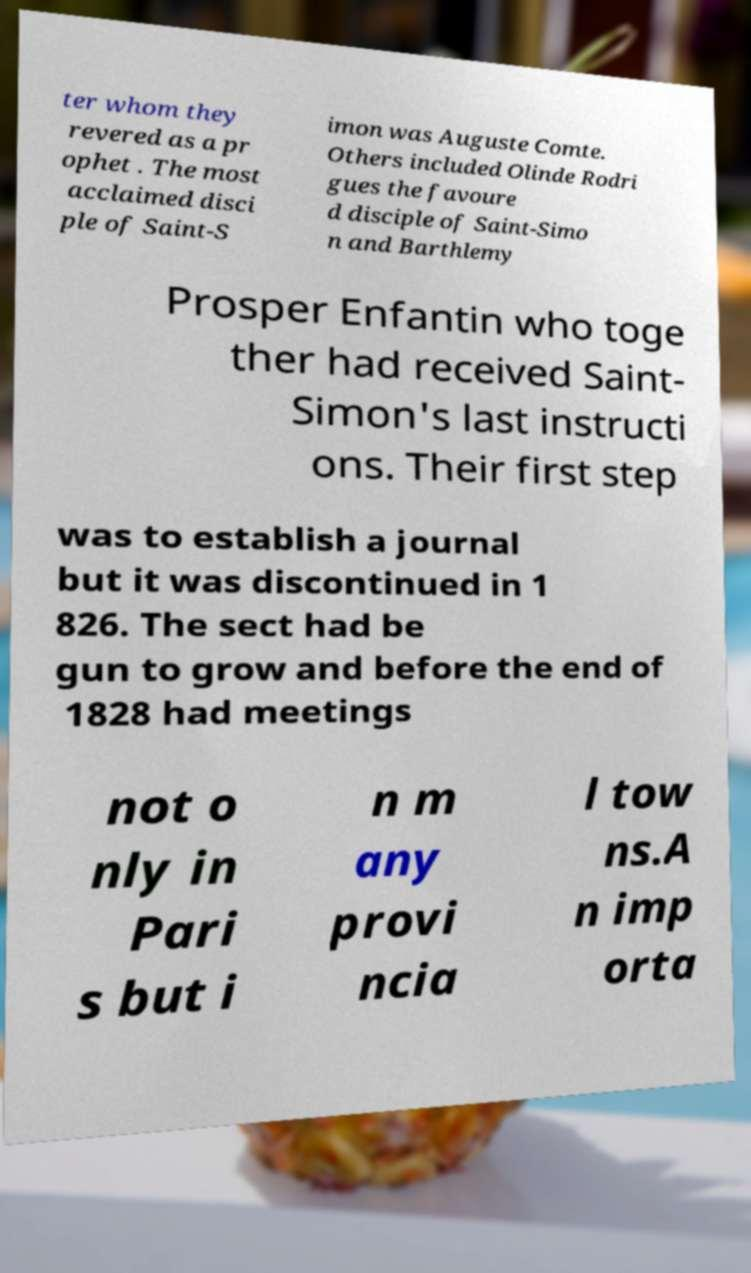I need the written content from this picture converted into text. Can you do that? ter whom they revered as a pr ophet . The most acclaimed disci ple of Saint-S imon was Auguste Comte. Others included Olinde Rodri gues the favoure d disciple of Saint-Simo n and Barthlemy Prosper Enfantin who toge ther had received Saint- Simon's last instructi ons. Their first step was to establish a journal but it was discontinued in 1 826. The sect had be gun to grow and before the end of 1828 had meetings not o nly in Pari s but i n m any provi ncia l tow ns.A n imp orta 